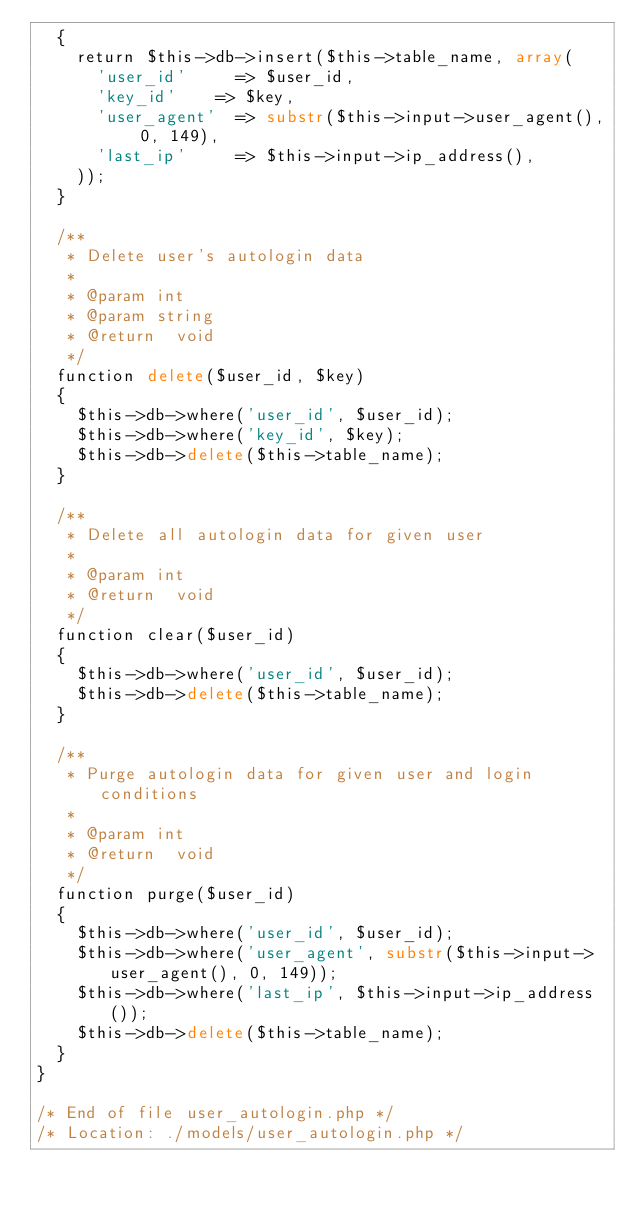<code> <loc_0><loc_0><loc_500><loc_500><_PHP_>	{
		return $this->db->insert($this->table_name, array(
			'user_id' 		=> $user_id,
			'key_id'	 	=> $key,
			'user_agent' 	=> substr($this->input->user_agent(), 0, 149),
			'last_ip' 		=> $this->input->ip_address(),
		));
	}

	/**
	 * Delete user's autologin data
	 *
	 * @param	int
	 * @param	string
	 * @return	void
	 */
	function delete($user_id, $key)
	{
		$this->db->where('user_id', $user_id);
		$this->db->where('key_id', $key);
		$this->db->delete($this->table_name);
	}

	/**
	 * Delete all autologin data for given user
	 *
	 * @param	int
	 * @return	void
	 */
	function clear($user_id)
	{
		$this->db->where('user_id', $user_id);
		$this->db->delete($this->table_name);
	}

	/**
	 * Purge autologin data for given user and login conditions
	 *
	 * @param	int
	 * @return	void
	 */
	function purge($user_id)
	{
		$this->db->where('user_id', $user_id);
		$this->db->where('user_agent', substr($this->input->user_agent(), 0, 149));
		$this->db->where('last_ip', $this->input->ip_address());
		$this->db->delete($this->table_name);
	}
}

/* End of file user_autologin.php */
/* Location: ./models/user_autologin.php */</code> 